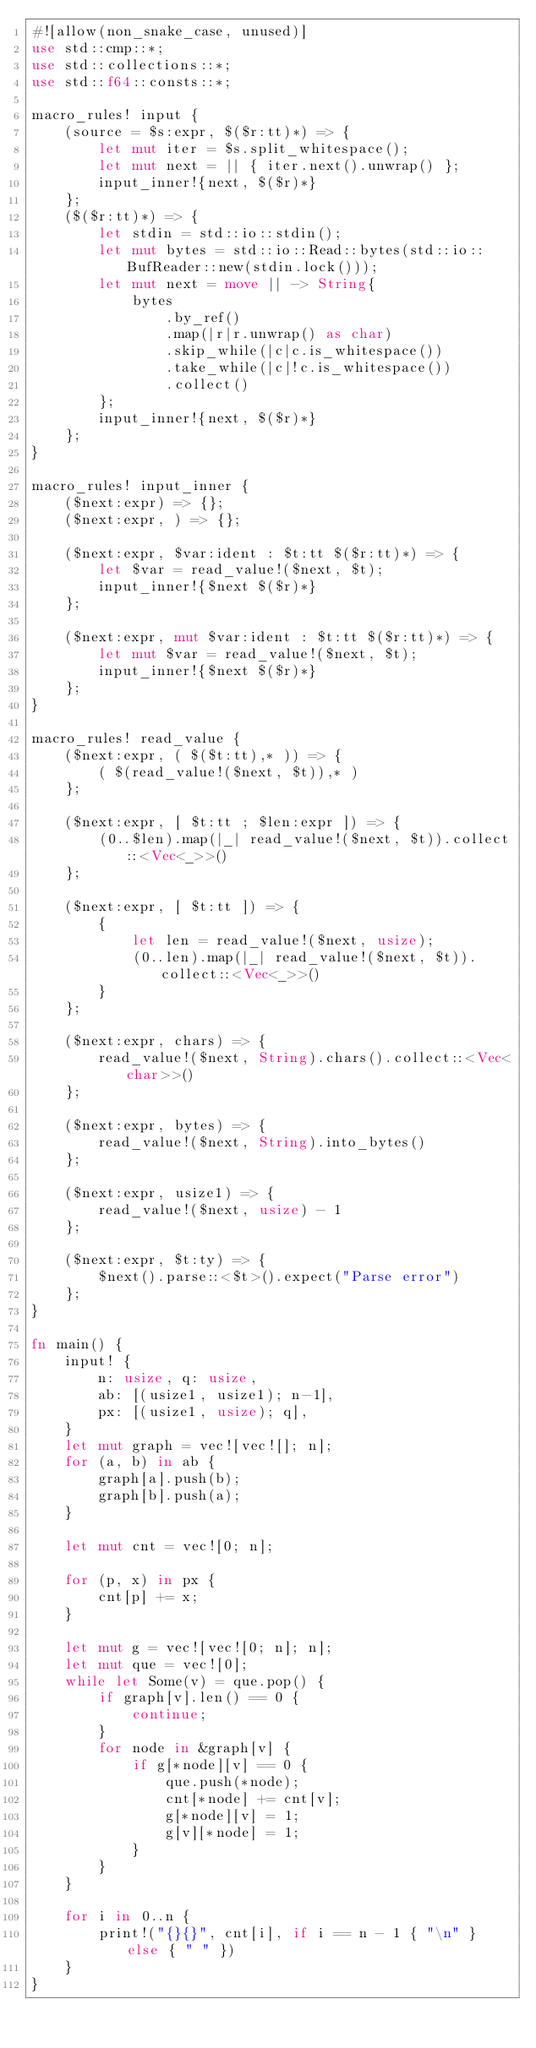Convert code to text. <code><loc_0><loc_0><loc_500><loc_500><_Rust_>#![allow(non_snake_case, unused)]
use std::cmp::*;
use std::collections::*;
use std::f64::consts::*;

macro_rules! input {
    (source = $s:expr, $($r:tt)*) => {
        let mut iter = $s.split_whitespace();
        let mut next = || { iter.next().unwrap() };
        input_inner!{next, $($r)*}
    };
    ($($r:tt)*) => {
        let stdin = std::io::stdin();
        let mut bytes = std::io::Read::bytes(std::io::BufReader::new(stdin.lock()));
        let mut next = move || -> String{
            bytes
                .by_ref()
                .map(|r|r.unwrap() as char)
                .skip_while(|c|c.is_whitespace())
                .take_while(|c|!c.is_whitespace())
                .collect()
        };
        input_inner!{next, $($r)*}
    };
}

macro_rules! input_inner {
    ($next:expr) => {};
    ($next:expr, ) => {};

    ($next:expr, $var:ident : $t:tt $($r:tt)*) => {
        let $var = read_value!($next, $t);
        input_inner!{$next $($r)*}
    };

    ($next:expr, mut $var:ident : $t:tt $($r:tt)*) => {
        let mut $var = read_value!($next, $t);
        input_inner!{$next $($r)*}
    };
}

macro_rules! read_value {
    ($next:expr, ( $($t:tt),* )) => {
        ( $(read_value!($next, $t)),* )
    };

    ($next:expr, [ $t:tt ; $len:expr ]) => {
        (0..$len).map(|_| read_value!($next, $t)).collect::<Vec<_>>()
    };

    ($next:expr, [ $t:tt ]) => {
        {
            let len = read_value!($next, usize);
            (0..len).map(|_| read_value!($next, $t)).collect::<Vec<_>>()
        }
    };

    ($next:expr, chars) => {
        read_value!($next, String).chars().collect::<Vec<char>>()
    };

    ($next:expr, bytes) => {
        read_value!($next, String).into_bytes()
    };

    ($next:expr, usize1) => {
        read_value!($next, usize) - 1
    };

    ($next:expr, $t:ty) => {
        $next().parse::<$t>().expect("Parse error")
    };
}

fn main() {
    input! {
        n: usize, q: usize,
        ab: [(usize1, usize1); n-1],
        px: [(usize1, usize); q],
    }
    let mut graph = vec![vec![]; n];
    for (a, b) in ab {
        graph[a].push(b);
        graph[b].push(a);
    }

    let mut cnt = vec![0; n];

    for (p, x) in px {
        cnt[p] += x;
    }

    let mut g = vec![vec![0; n]; n];
    let mut que = vec![0];
    while let Some(v) = que.pop() {
        if graph[v].len() == 0 {
            continue;
        }
        for node in &graph[v] {
            if g[*node][v] == 0 {
                que.push(*node);
                cnt[*node] += cnt[v];
                g[*node][v] = 1;
                g[v][*node] = 1;
            }
        }
    }

    for i in 0..n {
        print!("{}{}", cnt[i], if i == n - 1 { "\n" } else { " " })
    }
}
</code> 